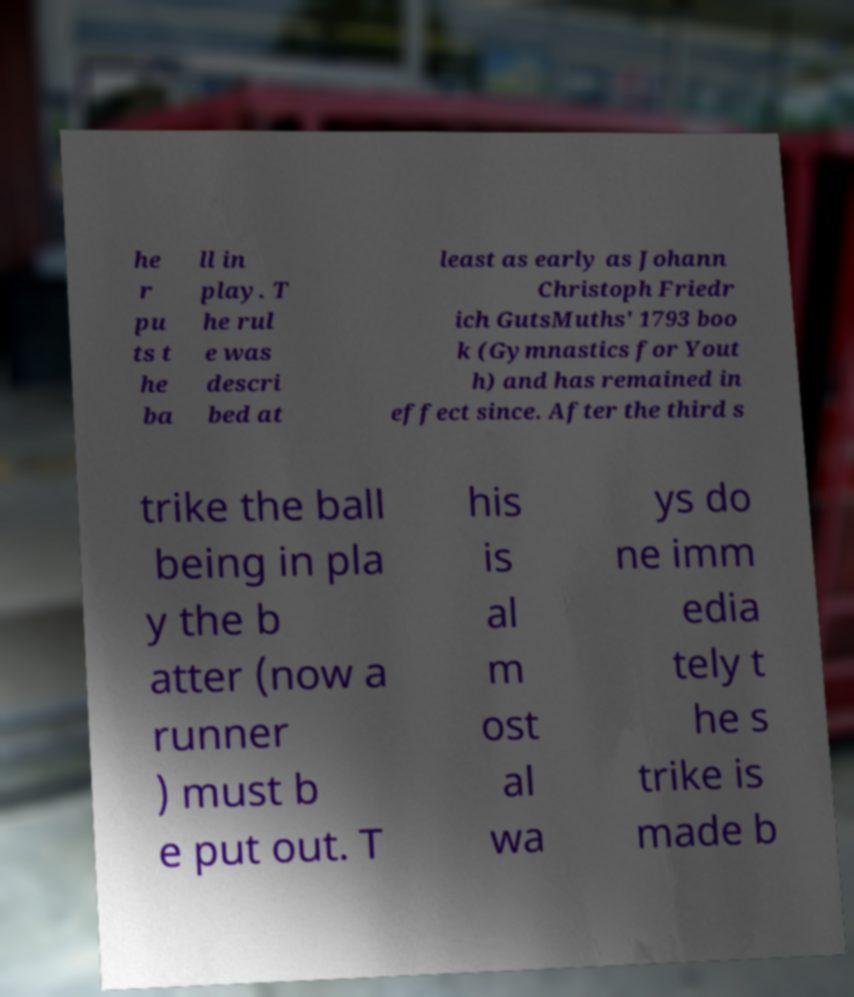For documentation purposes, I need the text within this image transcribed. Could you provide that? he r pu ts t he ba ll in play. T he rul e was descri bed at least as early as Johann Christoph Friedr ich GutsMuths' 1793 boo k (Gymnastics for Yout h) and has remained in effect since. After the third s trike the ball being in pla y the b atter (now a runner ) must b e put out. T his is al m ost al wa ys do ne imm edia tely t he s trike is made b 